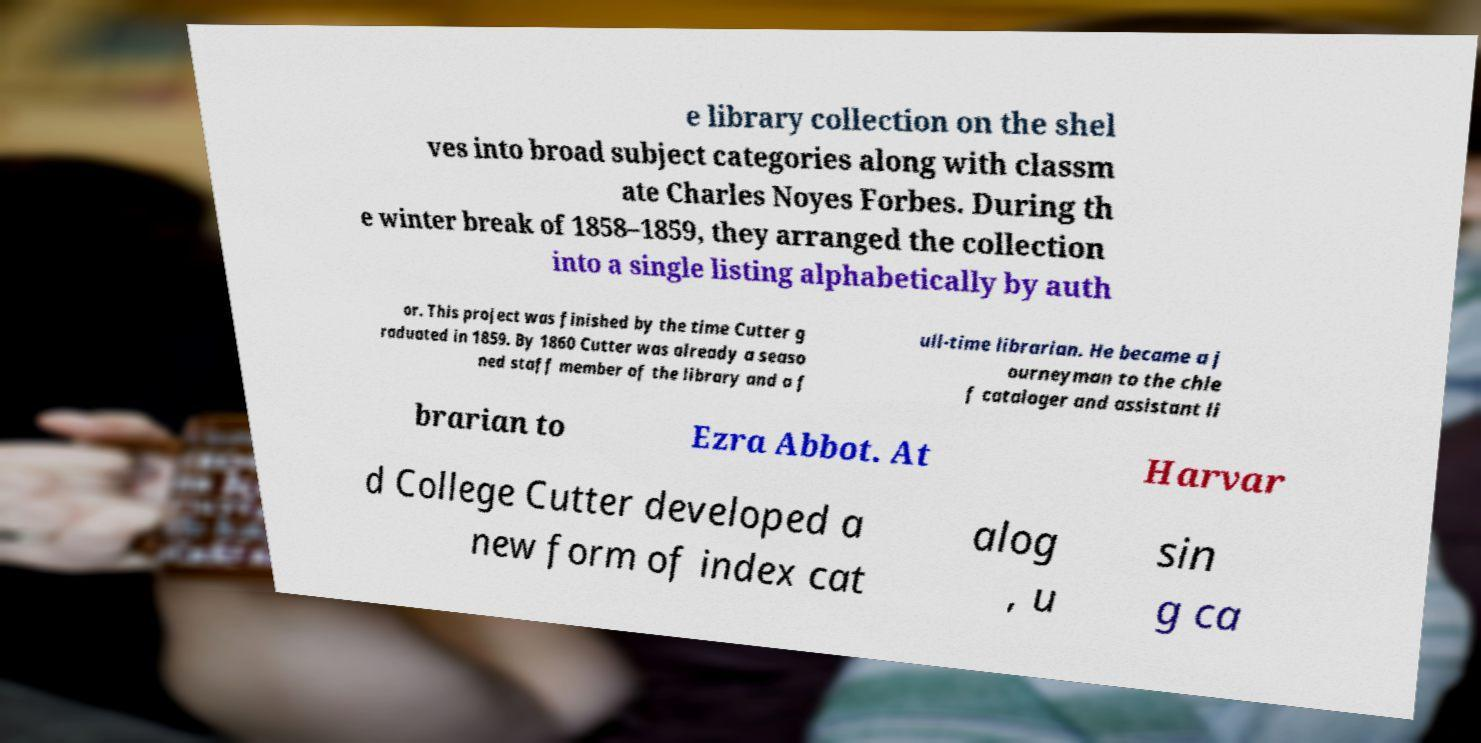I need the written content from this picture converted into text. Can you do that? e library collection on the shel ves into broad subject categories along with classm ate Charles Noyes Forbes. During th e winter break of 1858–1859, they arranged the collection into a single listing alphabetically by auth or. This project was finished by the time Cutter g raduated in 1859. By 1860 Cutter was already a seaso ned staff member of the library and a f ull-time librarian. He became a j ourneyman to the chie f cataloger and assistant li brarian to Ezra Abbot. At Harvar d College Cutter developed a new form of index cat alog , u sin g ca 